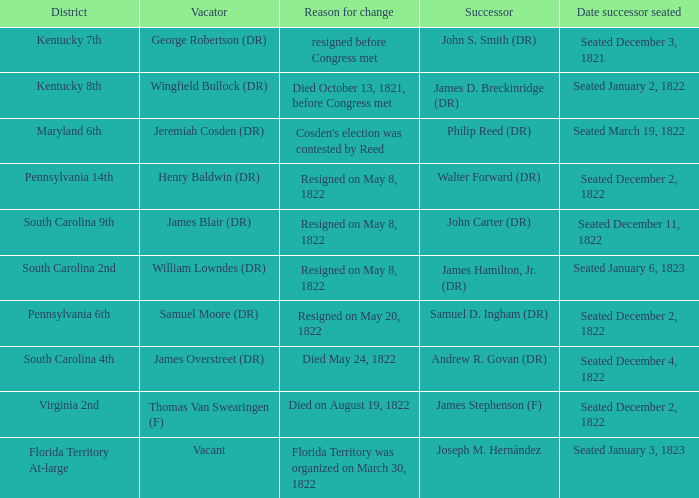Who is the successor when florida territory at-large is the area? Joseph M. Hernández. 